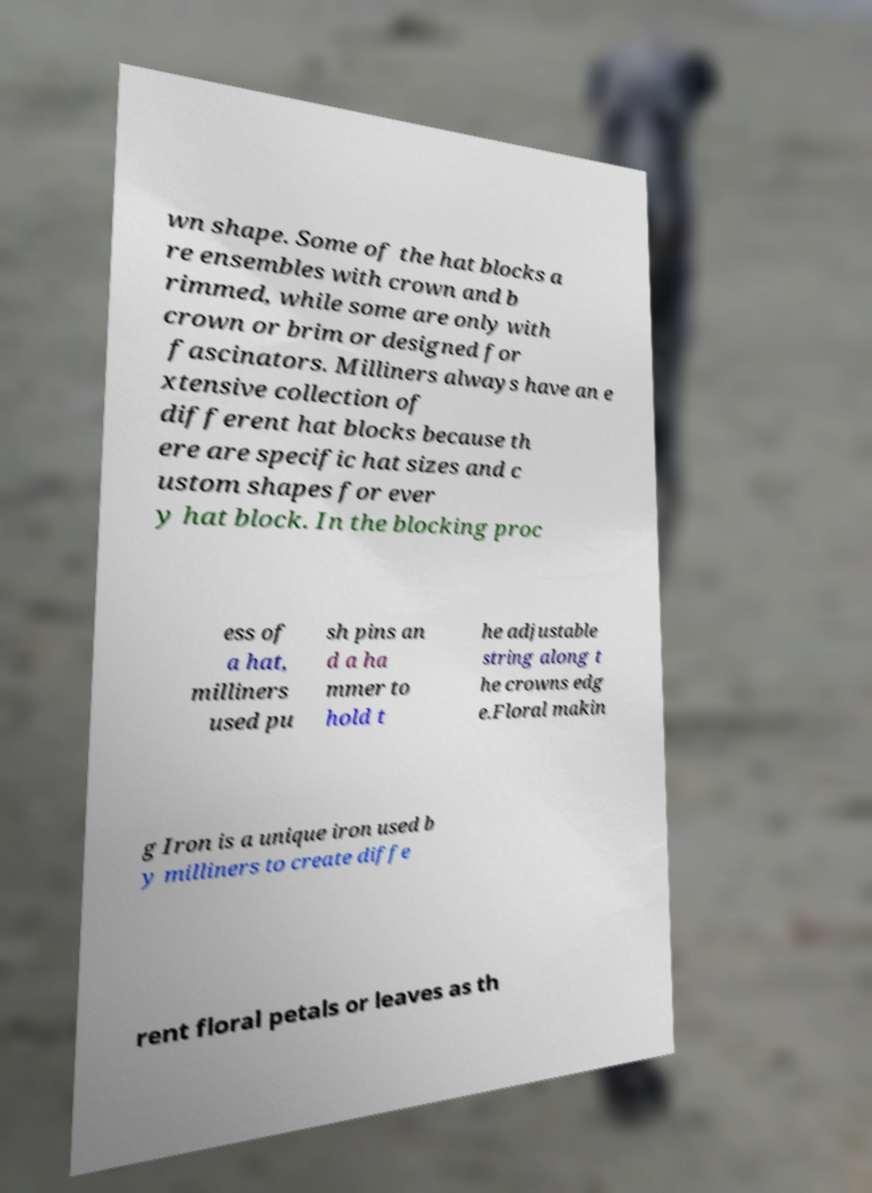Could you extract and type out the text from this image? wn shape. Some of the hat blocks a re ensembles with crown and b rimmed, while some are only with crown or brim or designed for fascinators. Milliners always have an e xtensive collection of different hat blocks because th ere are specific hat sizes and c ustom shapes for ever y hat block. In the blocking proc ess of a hat, milliners used pu sh pins an d a ha mmer to hold t he adjustable string along t he crowns edg e.Floral makin g Iron is a unique iron used b y milliners to create diffe rent floral petals or leaves as th 